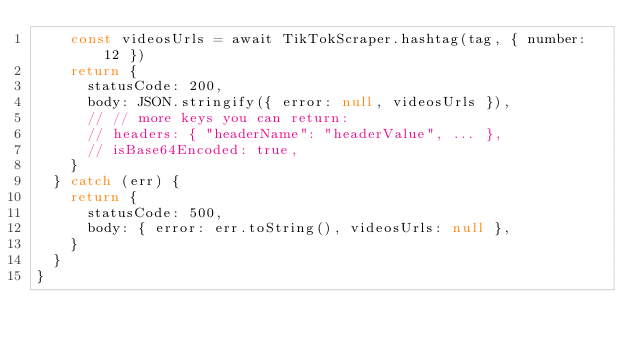<code> <loc_0><loc_0><loc_500><loc_500><_JavaScript_>    const videosUrls = await TikTokScraper.hashtag(tag, { number: 12 })
    return {
      statusCode: 200,
      body: JSON.stringify({ error: null, videosUrls }),
      // // more keys you can return:
      // headers: { "headerName": "headerValue", ... },
      // isBase64Encoded: true,
    }
  } catch (err) {
    return {
      statusCode: 500,
      body: { error: err.toString(), videosUrls: null },
    }
  }
}
</code> 